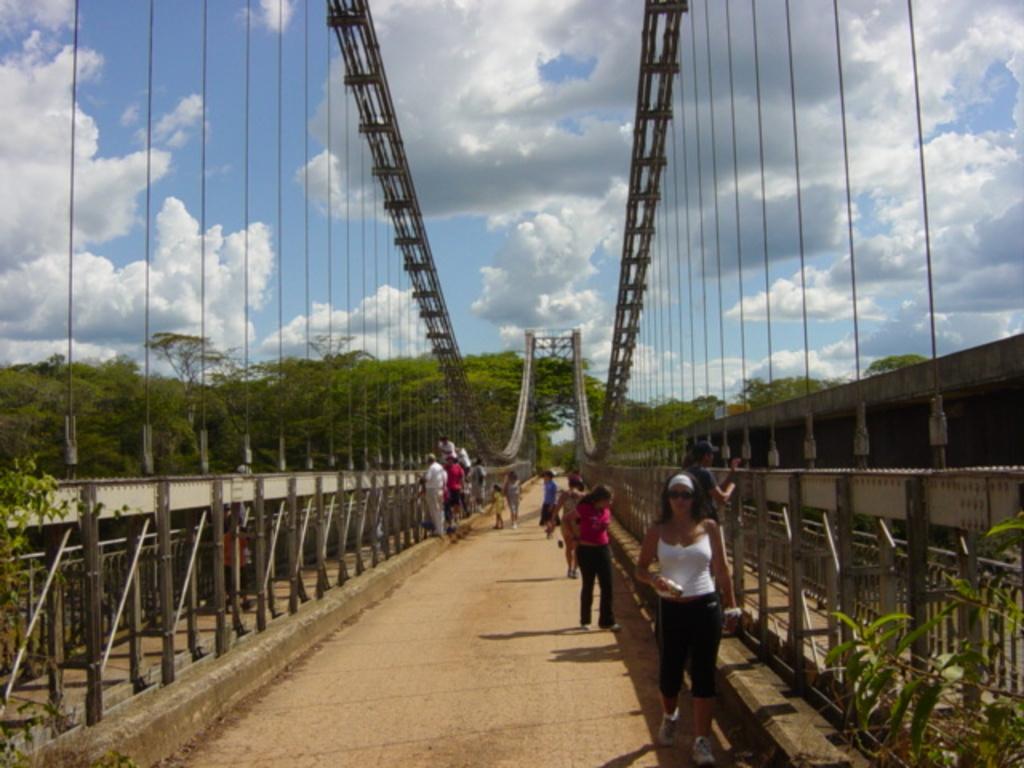In one or two sentences, can you explain what this image depicts? In this image we can see a few people standing and few people walking on the bridge. And right side, we can see the wall and left side, we can see the fence. And there are plants, trees and cloudy sky in the background. 